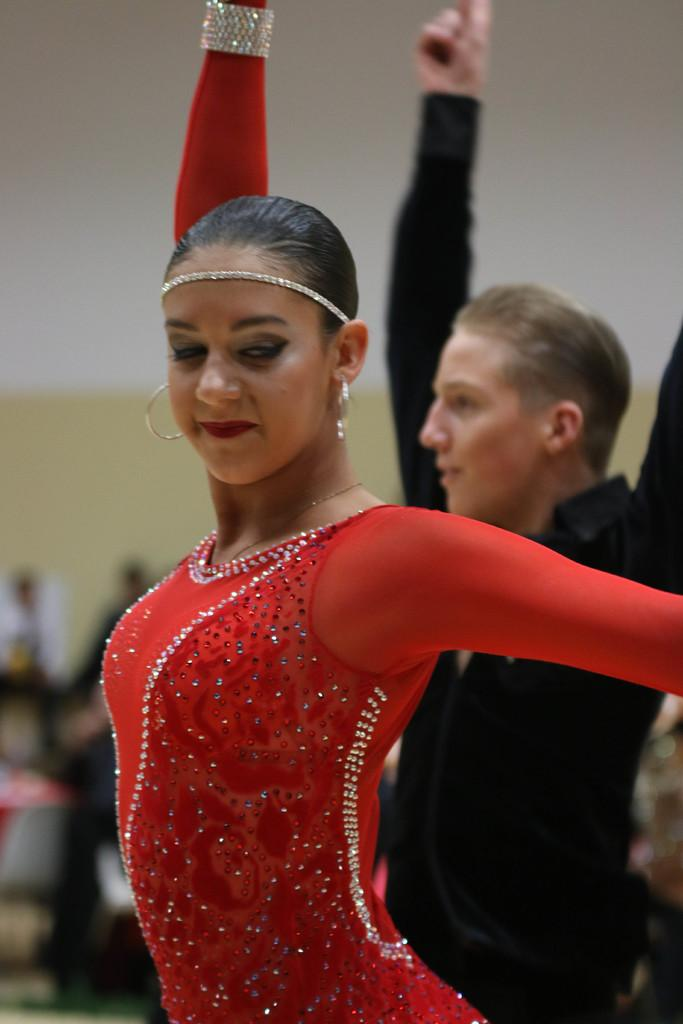What are the two main subjects in the image doing? There is a lady and a man dancing in the center of the image. What can be seen in the background of the image? There are people and a wall in the background of the image. What type of education can be seen in the image? There is no reference to education in the image; it features a lady and a man dancing, with people and a wall in the background. 